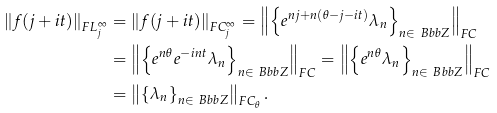<formula> <loc_0><loc_0><loc_500><loc_500>\left \| f ( j + i t ) \right \| _ { F L _ { j } ^ { \infty } } & = \left \| f ( j + i t ) \right \| _ { F C _ { j } ^ { \infty } } = \left \| \left \{ e ^ { n j + n ( \theta - j - i t ) } \lambda _ { n } \right \} _ { n \in \ B b b { Z } } \right \| _ { F C } \\ & = \left \| \left \{ e ^ { n \theta } e ^ { - i n t } \lambda _ { n } \right \} _ { n \in \ B b b { Z } } \right \| _ { F C } = \left \| \left \{ e ^ { n \theta } \lambda _ { n } \right \} _ { n \in \ B b b { Z } } \right \| _ { F C } \\ & = \left \| \left \{ \lambda _ { n } \right \} _ { n \in \ B b b { Z } } \right \| _ { F C _ { \theta } } .</formula> 